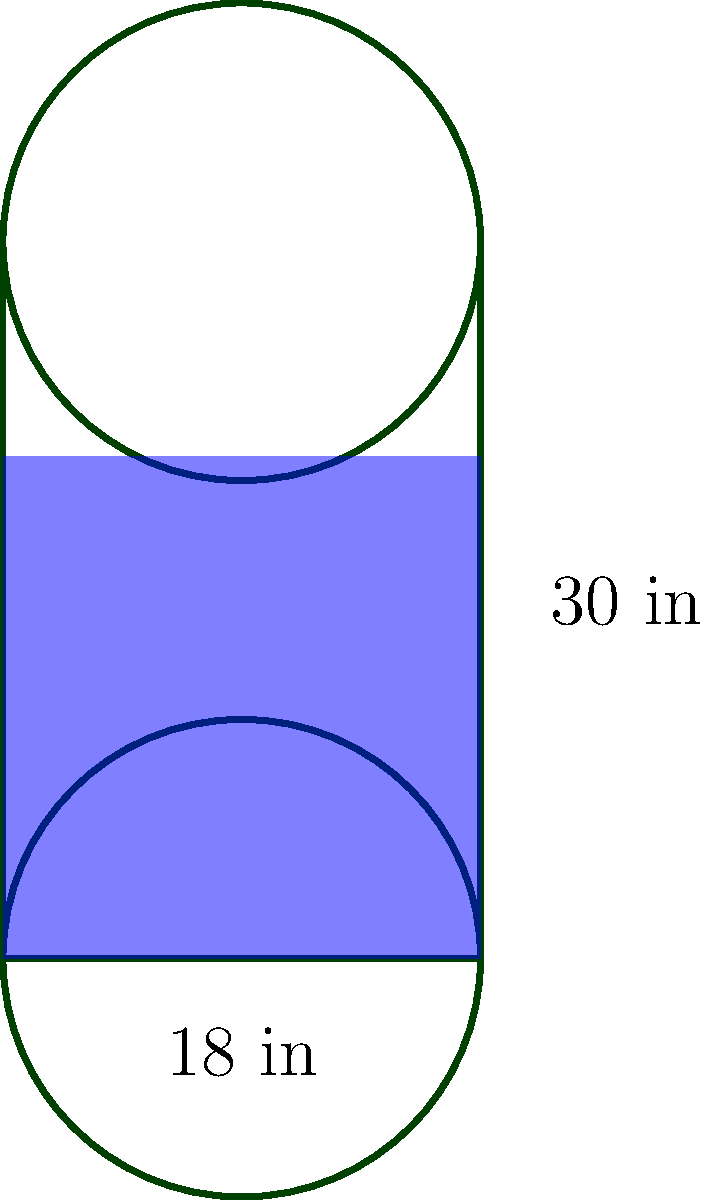As part of your rainwater harvesting system, you have installed a cylindrical rain barrel with a diameter of 18 inches and a height of 30 inches. After a recent rainfall, you notice that the barrel is 70% full. Calculate the volume of rainwater collected in cubic feet, rounded to two decimal places. To solve this problem, let's follow these steps:

1) First, we need to calculate the volume of the entire barrel:
   The volume of a cylinder is given by the formula: $V = \pi r^2 h$
   Where $r$ is the radius and $h$ is the height.

2) Convert the diameter to radius:
   Radius = Diameter / 2 = 18 inches / 2 = 9 inches

3) Convert height to feet:
   30 inches = 30 / 12 = 2.5 feet

4) Now, let's calculate the volume:
   $V = \pi (9/12)^2 (2.5)$
   $= \pi (0.75)^2 (2.5)$
   $= \pi (0.5625) (2.5)$
   $= 4.4179$ cubic feet

5) But the barrel is only 70% full, so we need to calculate 70% of this volume:
   $4.4179 \times 0.70 = 3.0925$ cubic feet

6) Rounding to two decimal places:
   3.09 cubic feet

Therefore, the volume of rainwater collected is 3.09 cubic feet.
Answer: 3.09 cubic feet 